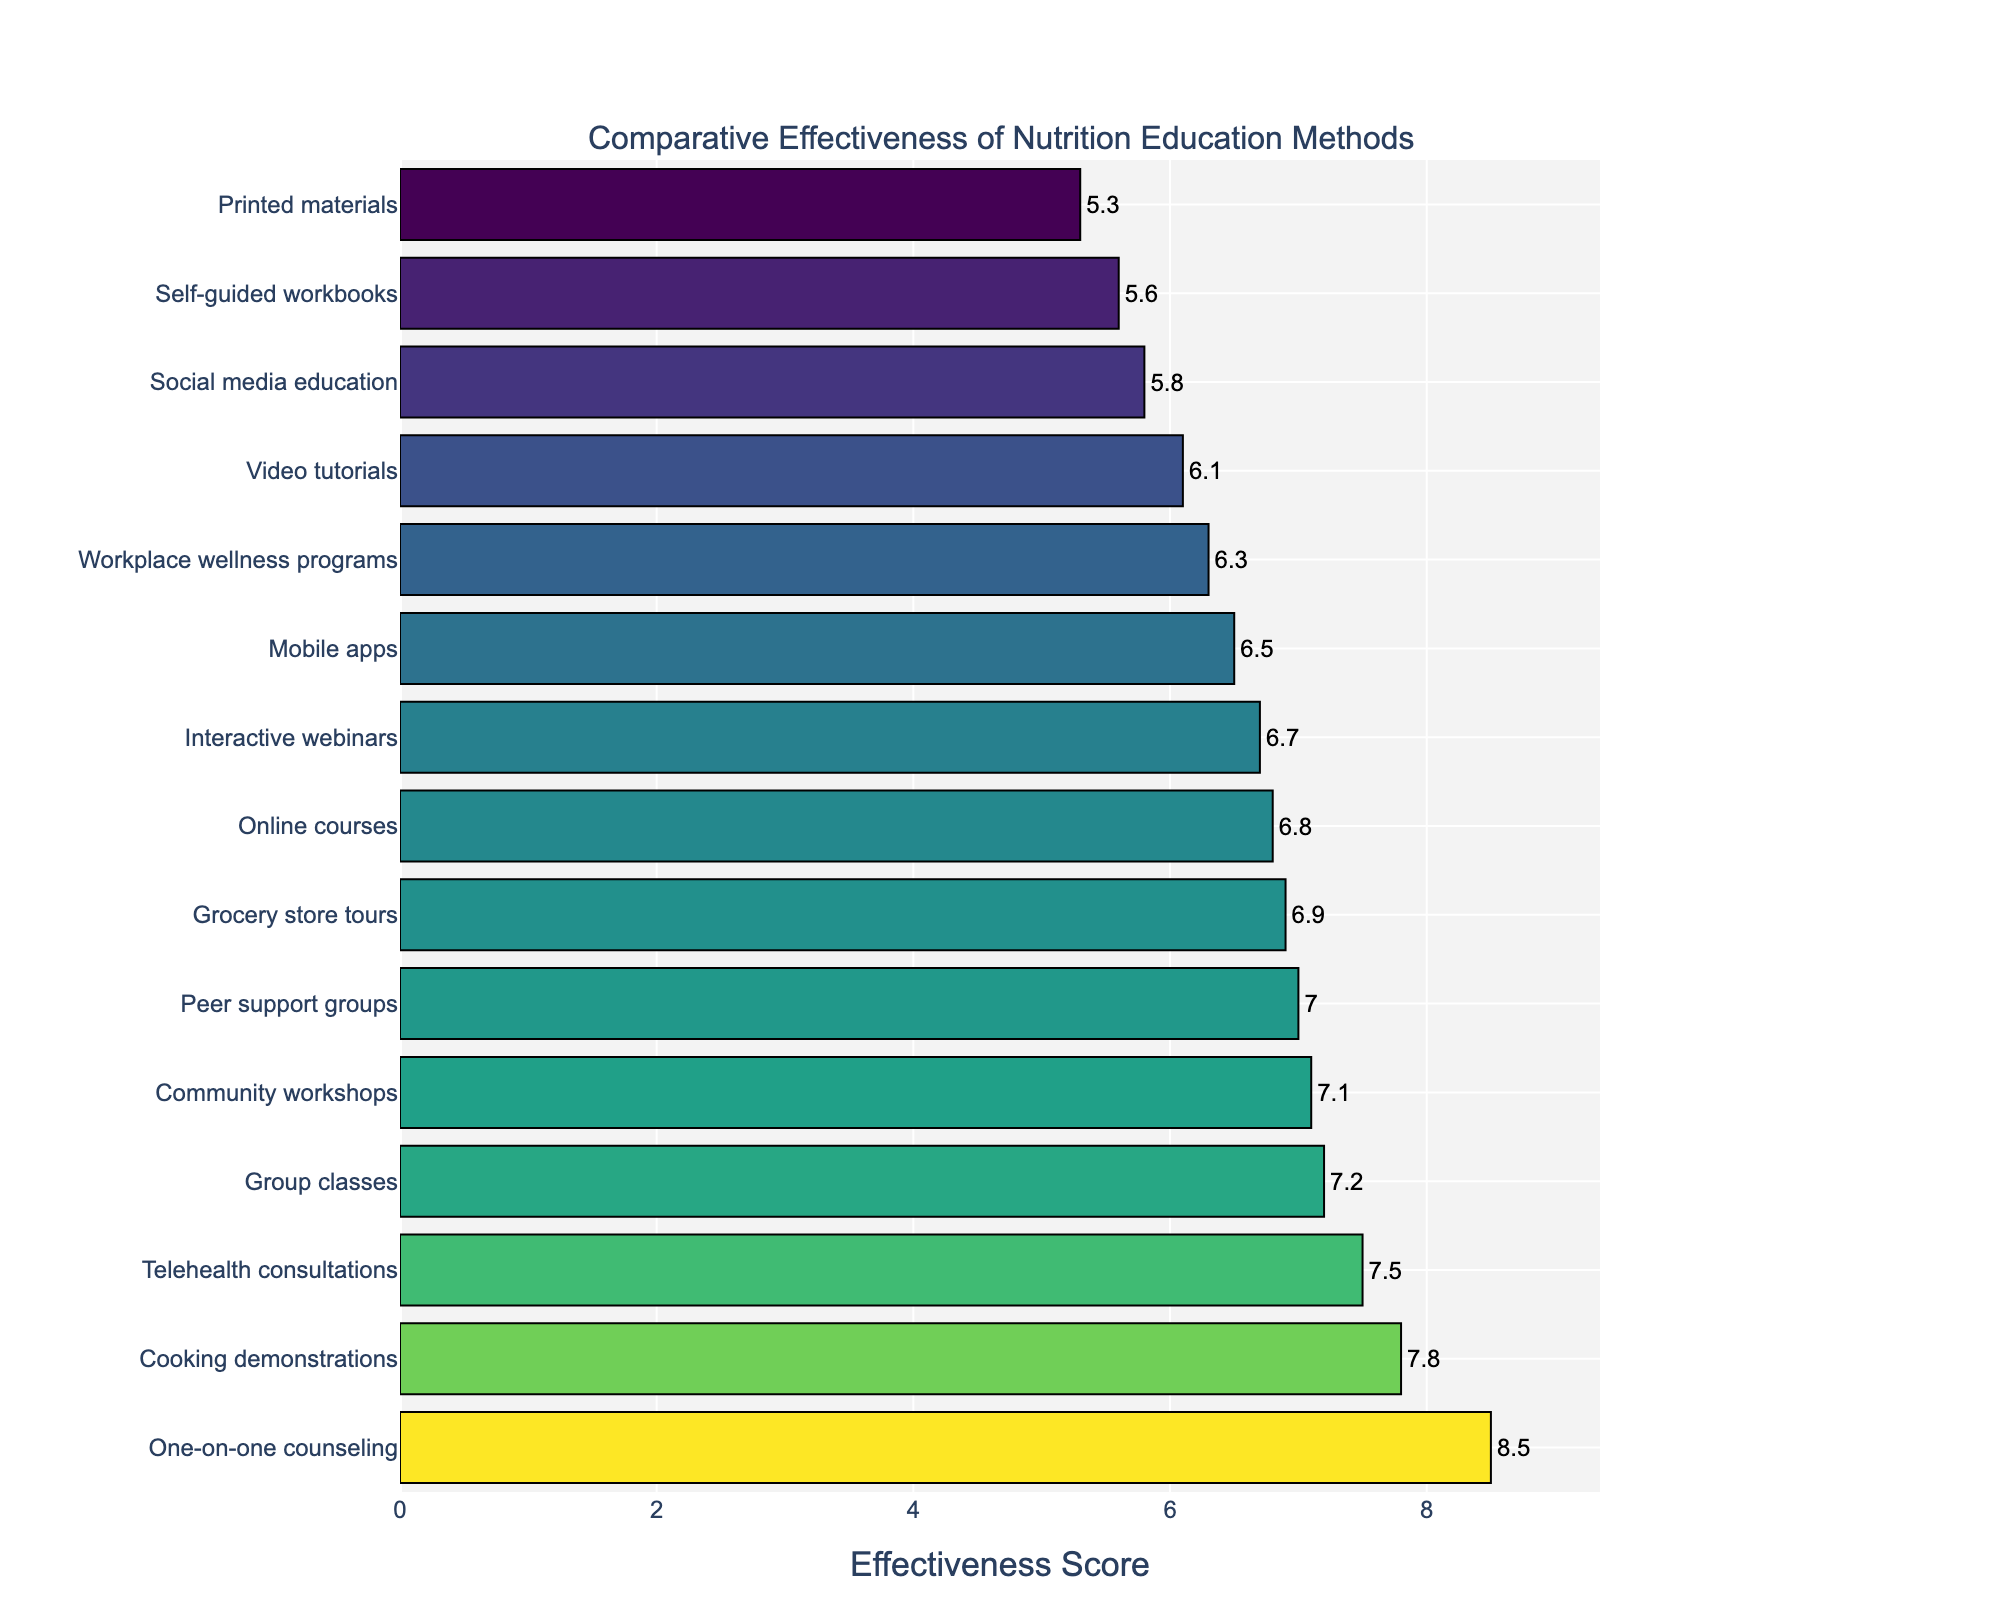What's the most effective nutrition education method according to the plot? The plot shows various nutrition education methods ranked by their effectiveness scores. The method with the highest score is at the top of the bar chart.
Answer: One-on-one counseling Which nutrition education method scored lowest in effectiveness? The method with the lowest effectiveness score will be located at the bottom of the bar chart.
Answer: Printed materials How much more effective is One-on-one counseling compared to Social media education? Locate the effectiveness scores for both methods from the bar chart. One-on-one counseling has a score of 8.5 and Social media education has a score of 5.8. Subtract the smaller score from the larger one: 8.5 - 5.8.
Answer: 2.7 Out of Group classes, Cooking demonstrations, and Telehealth consultations, which has the highest effectiveness score and what is it? Check the effectiveness scores for Group classes (7.2), Cooking demonstrations (7.8), and Telehealth consultations (7.5). The highest score among them is 7.8 for Cooking demonstrations.
Answer: Cooking demonstrations, 7.8 Calculate the average effectiveness score for Online courses, Mobile apps, and Video tutorials. Identify the scores for Online courses (6.8), Mobile apps (6.5), and Video tutorials (6.1). Add them together and divide by 3 to find the average: (6.8 + 6.5 + 6.1) / 3.
Answer: 6.47 Which methods have an effectiveness score higher than 7 but lower than 8? Identify methods on the bar chart that have scores within the range of 7 to 8. These are Cooking demonstrations (7.8), Telehealth consultations (7.5), Group classes (7.2), and Community workshops (7.1).
Answer: Cooking demonstrations, Telehealth consultations, Group classes, Community workshops How does the effectiveness score for Grocery store tours compare to that of Online courses? Locate the effectiveness scores for Grocery store tours (6.9) and Online courses (6.8). Compare the two values: 6.9 is slightly higher than 6.8.
Answer: Grocery store tours are slightly more effective What is the combined effectiveness score of Peer support groups and Interactive webinars? Find the effectiveness scores for Peer support groups (7.0) and Interactive webinars (6.7). Add the scores together: 7.0 + 6.7.
Answer: 13.7 How much less effective is Printed materials compared to the average of One-on-one counseling and Group classes? Effectiveness scores for Printed materials (5.3), One-on-one counseling (8.5), and Group classes (7.2). Calculate the average for One-on-one counseling and Group classes: (8.5 + 7.2) / 2 = 7.85. Then subtract the effectiveness score of Printed materials: 7.85 - 5.3.
Answer: 2.55 What is the effectiveness score range in the bar chart? Identify the highest and lowest effectiveness scores. The highest is One-on-one counseling (8.5) and the lowest is Printed materials (5.3). Subtract the smallest score from the largest: 8.5 - 5.3.
Answer: 3.2 